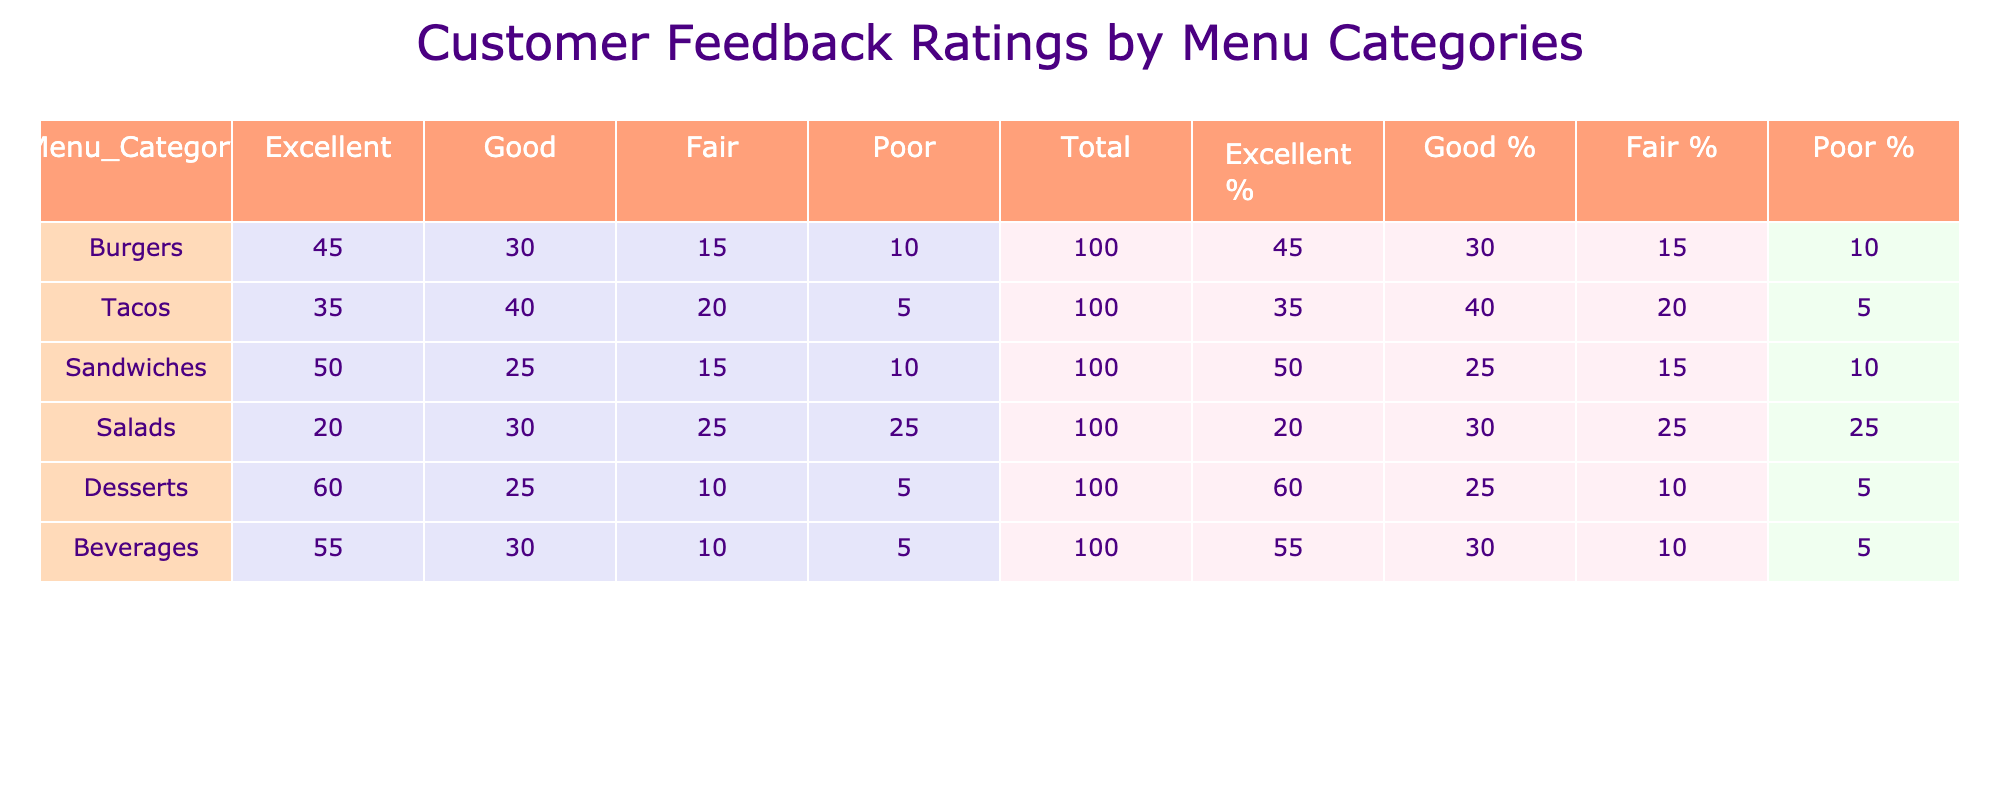What menu category received the most Excellent ratings? By reviewing the table, we observe the Excellent ratings for each category: Burgers (45), Tacos (35), Sandwiches (50), Salads (20), Desserts (60), and Beverages (55). The highest value among these is for Desserts with 60 ratings.
Answer: Desserts Which category had the lowest total feedback ratings? To find the lowest total feedback ratings, we need to sum the ratings for each menu category: Burgers (100), Tacos (100), Sandwiches (100), Salads (100), Desserts (100), and Beverages (100). All categories have the same total ratings of 100, which means no category stands out with a lower figure.
Answer: None; all are equal Is it true that Tacos received more Good ratings than Salads? The table shows that Tacos received 40 Good ratings while Salads received 30 Good ratings. Therefore, Tacos indeed received more Good ratings than Salads.
Answer: Yes What is the percentage of Fair ratings for Sandwiches? For Sandwiches, the Fair rating is 15. To find the percentage, we first need to calculate the total ratings which is 100. The percentage is (15/100) * 100 = 15%.
Answer: 15% If we compare Desserts and Beverages, which category has a higher total of Poor ratings and by how much? Looking at the Poor ratings: Desserts have 5, and Beverages also have 5. Calculating the difference shows that their Poor ratings are equal (5 - 5 = 0). Hence, neither category has a higher total of Poor ratings.
Answer: Equal; difference of 0 Which menu category had the highest percentage of Good ratings? To find this, we need to calculate the percentage of Good ratings for each menu category based on their total ratings. The percentages for Good ratings are: Burgers (30/100 * 100 = 30%), Tacos (40/100 * 100 = 40%), Sandwiches (25/100 * 100 = 25%), Salads (30/100 * 100 = 30%), Desserts (25/100 * 100 = 25%), and Beverages (30/100 * 100 = 30%). Tacos have the highest percentage of Good ratings at 40%.
Answer: Tacos What is the average Poor rating across all menu categories? First, we note the Poor ratings for each category: Burgers (10), Tacos (5), Sandwiches (10), Salads (25), Desserts (5), Beverages (5). Summing these gives us (10 + 5 + 10 + 25 + 5 + 5 = 60). Then, divide by the number of categories, which is 6: 60/6 = 10.
Answer: 10 Do Salads have more Fair ratings than Desserts? The table shows that Salads have 25 Fair ratings while Desserts have 10 Fair ratings. Thus, Salads have more Fair ratings than Desserts.
Answer: Yes 